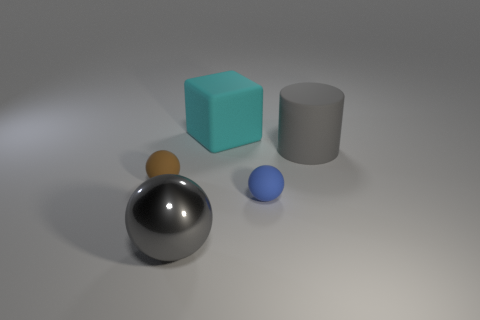Is the shape of the matte object left of the metallic thing the same as the gray thing on the right side of the large gray metallic sphere?
Give a very brief answer. No. What size is the gray object that is on the right side of the gray sphere?
Ensure brevity in your answer.  Large. What is the size of the object that is behind the big matte object that is right of the rubber block?
Make the answer very short. Large. Is the number of cyan matte objects greater than the number of things?
Give a very brief answer. No. Is the number of big metal objects that are behind the big metallic sphere greater than the number of big matte cylinders in front of the gray rubber cylinder?
Your answer should be very brief. No. What is the size of the matte object that is both on the right side of the cyan rubber object and behind the tiny blue matte sphere?
Offer a very short reply. Large. How many cyan rubber objects are the same size as the blue matte thing?
Keep it short and to the point. 0. There is a thing that is the same color as the large cylinder; what is its material?
Give a very brief answer. Metal. There is a tiny thing on the right side of the large gray sphere; does it have the same shape as the cyan rubber thing?
Offer a terse response. No. Is the number of gray matte cylinders that are left of the brown matte thing less than the number of big gray objects?
Offer a terse response. Yes. 